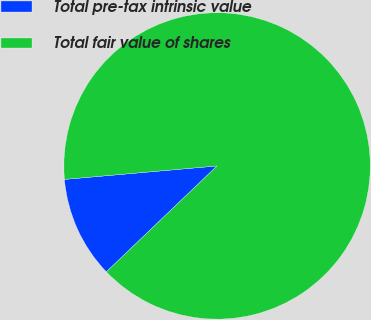Convert chart to OTSL. <chart><loc_0><loc_0><loc_500><loc_500><pie_chart><fcel>Total pre-tax intrinsic value<fcel>Total fair value of shares<nl><fcel>10.75%<fcel>89.25%<nl></chart> 